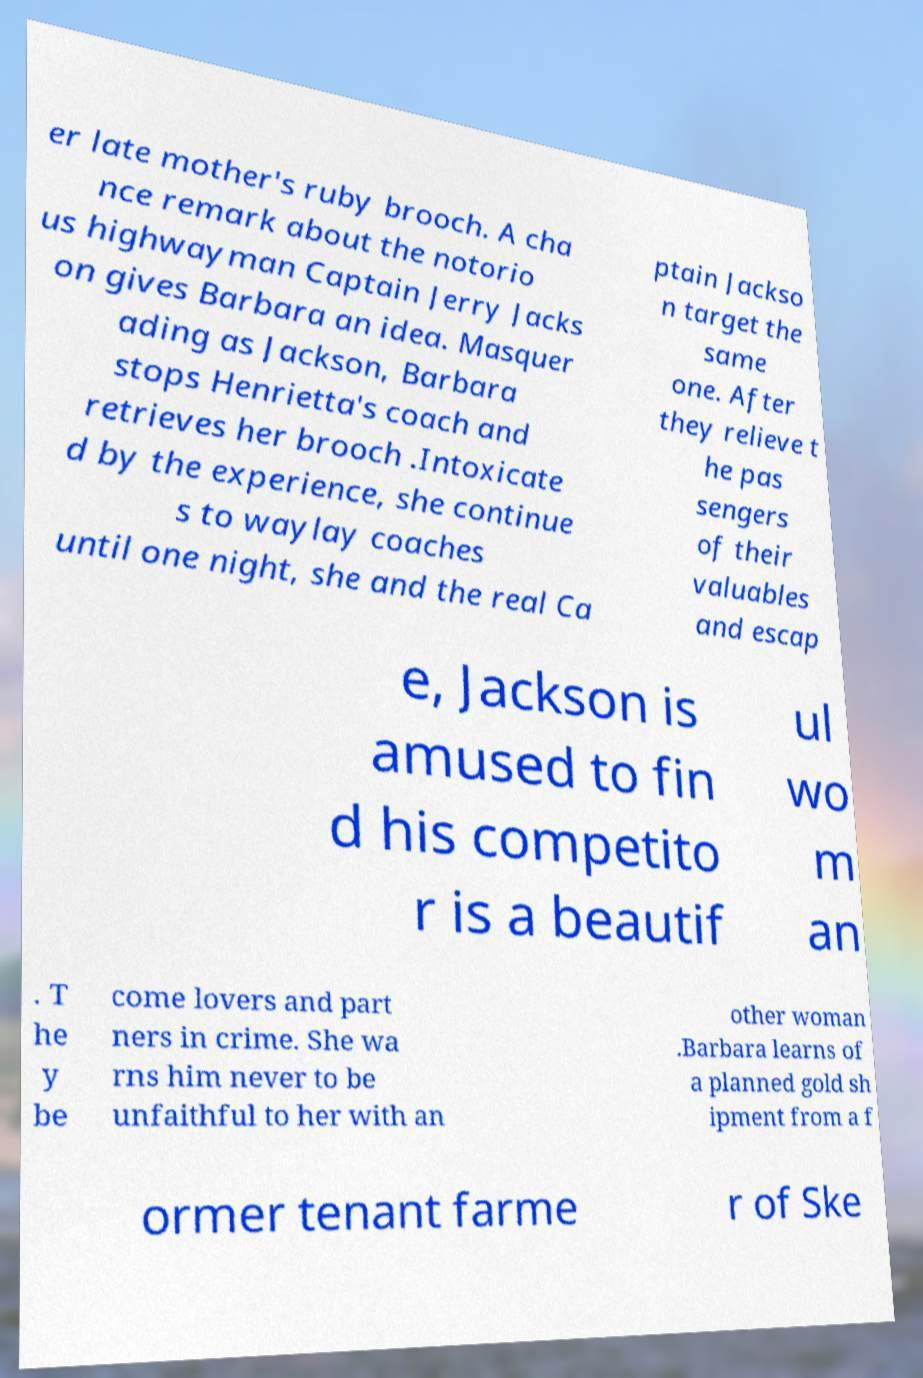Can you accurately transcribe the text from the provided image for me? er late mother's ruby brooch. A cha nce remark about the notorio us highwayman Captain Jerry Jacks on gives Barbara an idea. Masquer ading as Jackson, Barbara stops Henrietta's coach and retrieves her brooch .Intoxicate d by the experience, she continue s to waylay coaches until one night, she and the real Ca ptain Jackso n target the same one. After they relieve t he pas sengers of their valuables and escap e, Jackson is amused to fin d his competito r is a beautif ul wo m an . T he y be come lovers and part ners in crime. She wa rns him never to be unfaithful to her with an other woman .Barbara learns of a planned gold sh ipment from a f ormer tenant farme r of Ske 